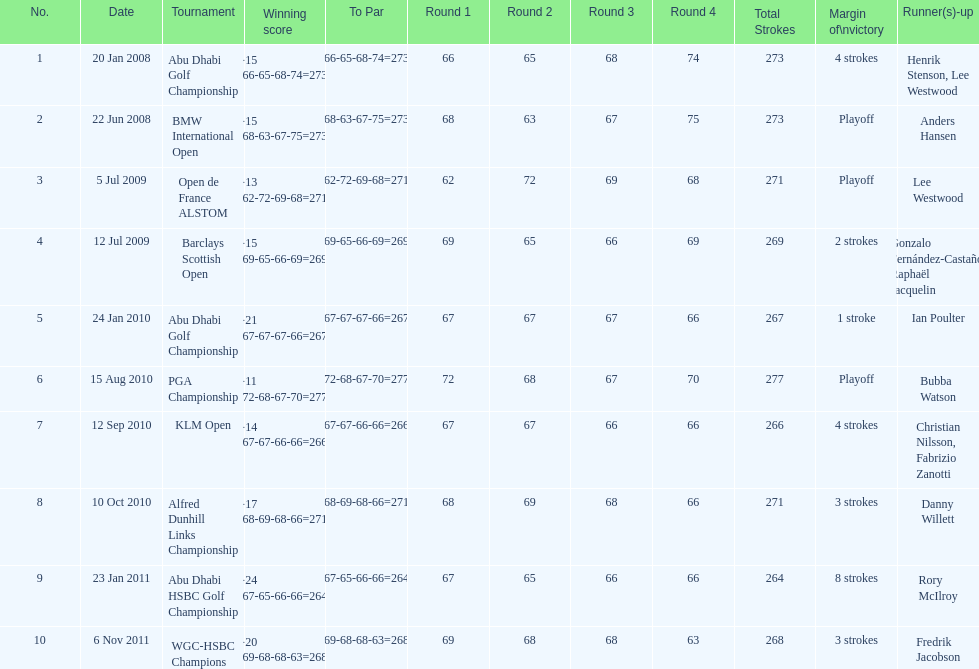What were the margins of victories of the tournaments? 4 strokes, Playoff, Playoff, 2 strokes, 1 stroke, Playoff, 4 strokes, 3 strokes, 8 strokes, 3 strokes. Of these, what was the margin of victory of the klm and the barklay 2 strokes, 4 strokes. What were the difference between these? 2 strokes. 